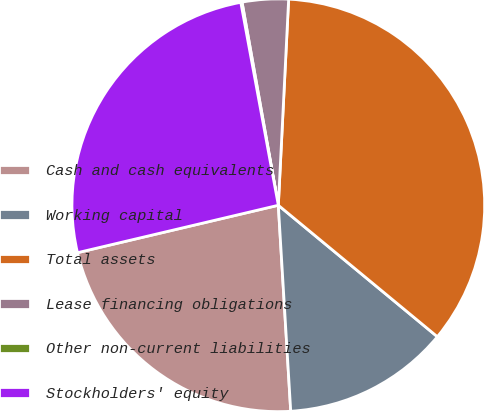Convert chart to OTSL. <chart><loc_0><loc_0><loc_500><loc_500><pie_chart><fcel>Cash and cash equivalents<fcel>Working capital<fcel>Total assets<fcel>Lease financing obligations<fcel>Other non-current liabilities<fcel>Stockholders' equity<nl><fcel>22.27%<fcel>13.05%<fcel>35.2%<fcel>3.61%<fcel>0.1%<fcel>25.78%<nl></chart> 